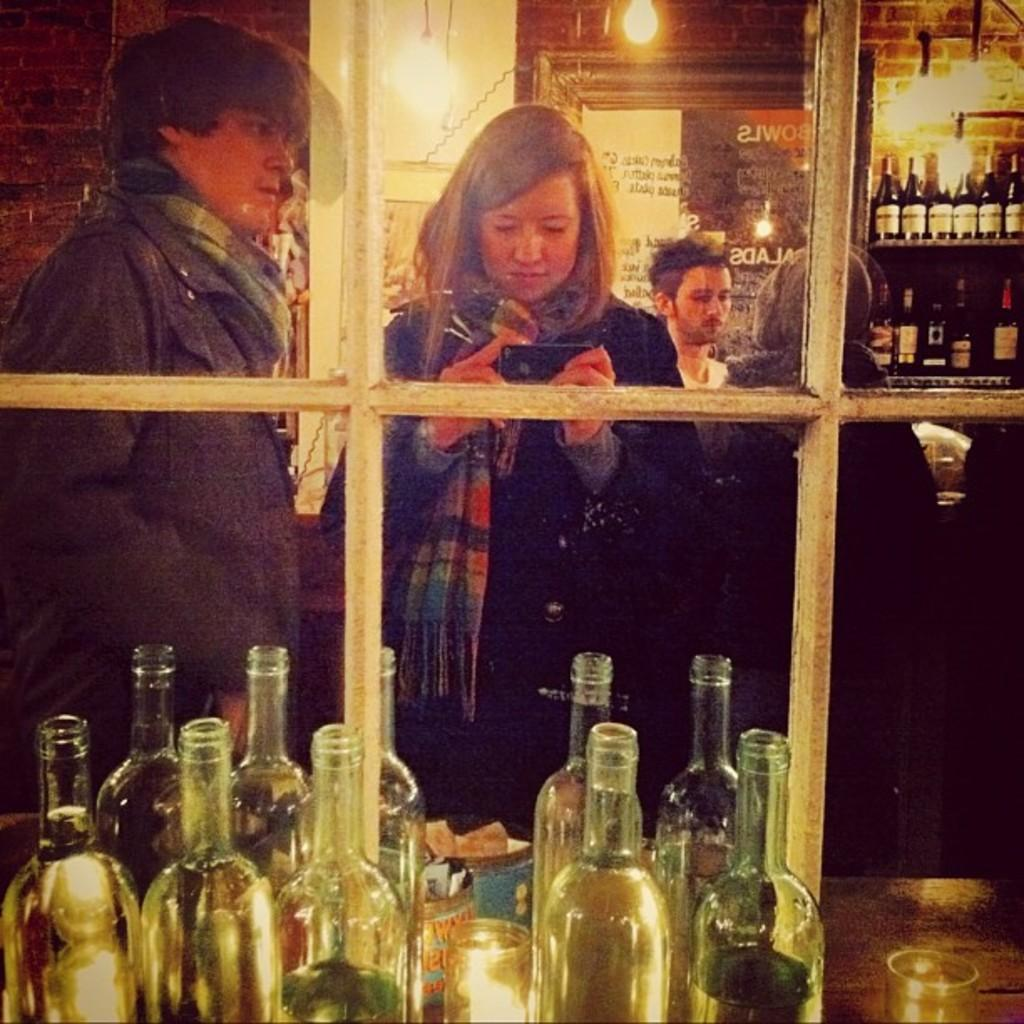Who or what is present in the image? There are people in the image. What are the people doing in the image? The people are standing in front of a table and taking a picture. What can be seen on the table in the image? There are bottles on the table. Is there any reflective surface in the image? Yes, there is a mirror in the image. What type of toy can be seen in the mirror in the image? There is no toy present in the image, and therefore none can be seen in the mirror. 